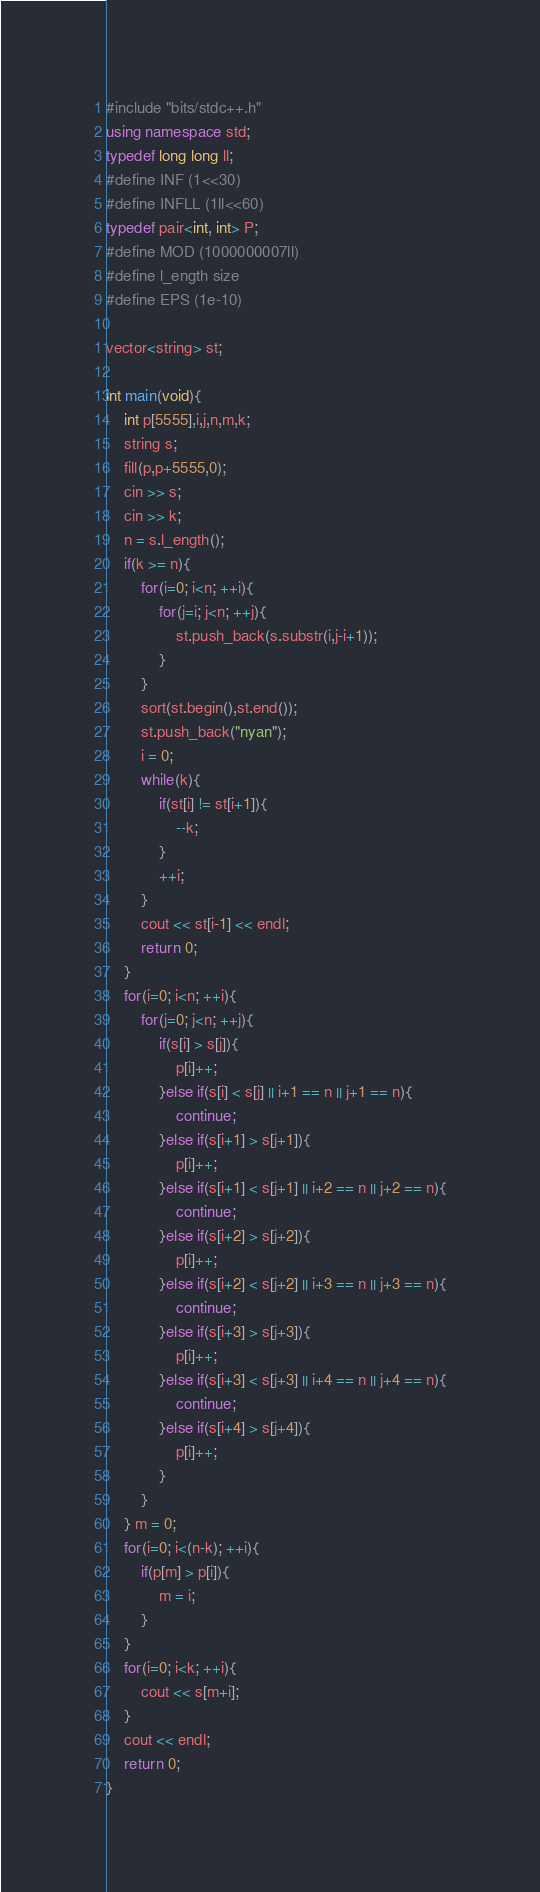Convert code to text. <code><loc_0><loc_0><loc_500><loc_500><_C++_>#include "bits/stdc++.h"
using namespace std;
typedef long long ll;
#define INF (1<<30)
#define INFLL (1ll<<60)
typedef pair<int, int> P;
#define MOD (1000000007ll)
#define l_ength size
#define EPS (1e-10)

vector<string> st;

int main(void){
	int p[5555],i,j,n,m,k;
	string s;
	fill(p,p+5555,0);
	cin >> s;
	cin >> k;
	n = s.l_ength();
	if(k >= n){
		for(i=0; i<n; ++i){
			for(j=i; j<n; ++j){
				st.push_back(s.substr(i,j-i+1));
			}
		}
		sort(st.begin(),st.end());
		st.push_back("nyan");
		i = 0;
		while(k){
			if(st[i] != st[i+1]){
				--k;
			}
			++i;
		}
		cout << st[i-1] << endl;
		return 0;
	}
	for(i=0; i<n; ++i){
		for(j=0; j<n; ++j){
			if(s[i] > s[j]){
				p[i]++;
			}else if(s[i] < s[j] || i+1 == n || j+1 == n){
				continue;
			}else if(s[i+1] > s[j+1]){
				p[i]++;
			}else if(s[i+1] < s[j+1] || i+2 == n || j+2 == n){
				continue;
			}else if(s[i+2] > s[j+2]){
				p[i]++;
			}else if(s[i+2] < s[j+2] || i+3 == n || j+3 == n){
				continue;
			}else if(s[i+3] > s[j+3]){
				p[i]++;
			}else if(s[i+3] < s[j+3] || i+4 == n || j+4 == n){
				continue;
			}else if(s[i+4] > s[j+4]){
				p[i]++;
			}
		}
	} m = 0;
	for(i=0; i<(n-k); ++i){
		if(p[m] > p[i]){
			m = i;
		}
	}
	for(i=0; i<k; ++i){
		cout << s[m+i];
	}
	cout << endl;
	return 0;
}
</code> 